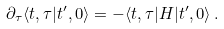Convert formula to latex. <formula><loc_0><loc_0><loc_500><loc_500>\partial _ { \tau } \langle t , \tau | t ^ { \prime } , 0 \rangle = - \langle t , \tau | H | t ^ { \prime } , 0 \rangle \, .</formula> 